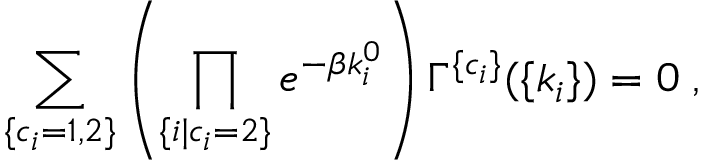<formula> <loc_0><loc_0><loc_500><loc_500>\sum _ { \{ c _ { i } = 1 , 2 \} } \left ( \prod _ { \{ i | c _ { i } = 2 \} } e ^ { - \beta k _ { i } ^ { 0 } } \right ) \Gamma ^ { \{ c _ { i } \} } ( \{ k _ { i } \} ) = 0 \, ,</formula> 